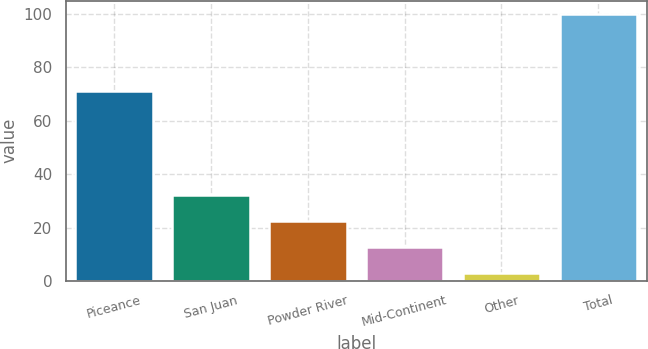<chart> <loc_0><loc_0><loc_500><loc_500><bar_chart><fcel>Piceance<fcel>San Juan<fcel>Powder River<fcel>Mid-Continent<fcel>Other<fcel>Total<nl><fcel>71<fcel>32.1<fcel>22.4<fcel>12.7<fcel>3<fcel>100<nl></chart> 